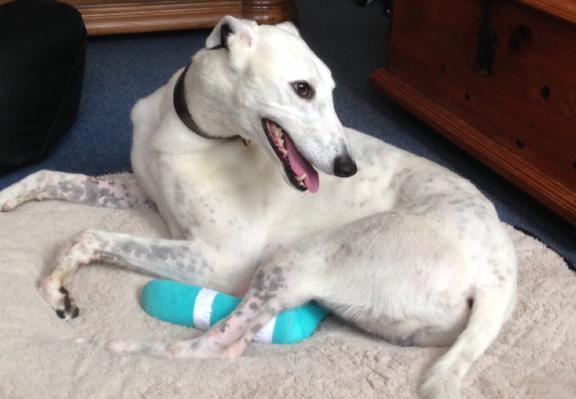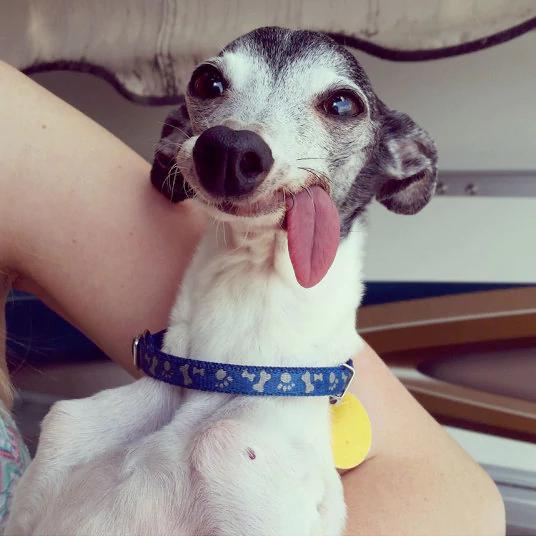The first image is the image on the left, the second image is the image on the right. For the images shown, is this caption "A dog is lying on the floor with its head up in the left image." true? Answer yes or no. Yes. The first image is the image on the left, the second image is the image on the right. Analyze the images presented: Is the assertion "An image shows a human limb touching a hound with its tongue hanging to the right." valid? Answer yes or no. Yes. 